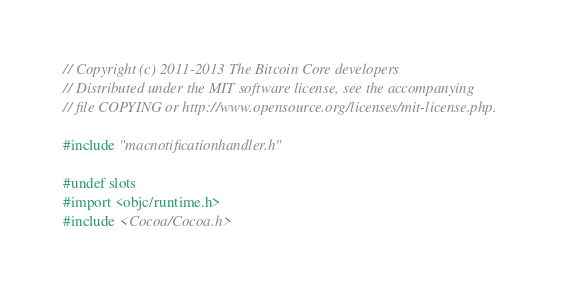Convert code to text. <code><loc_0><loc_0><loc_500><loc_500><_ObjectiveC_>// Copyright (c) 2011-2013 The Bitcoin Core developers
// Distributed under the MIT software license, see the accompanying
// file COPYING or http://www.opensource.org/licenses/mit-license.php.

#include "macnotificationhandler.h"

#undef slots
#import <objc/runtime.h>
#include <Cocoa/Cocoa.h>
</code> 